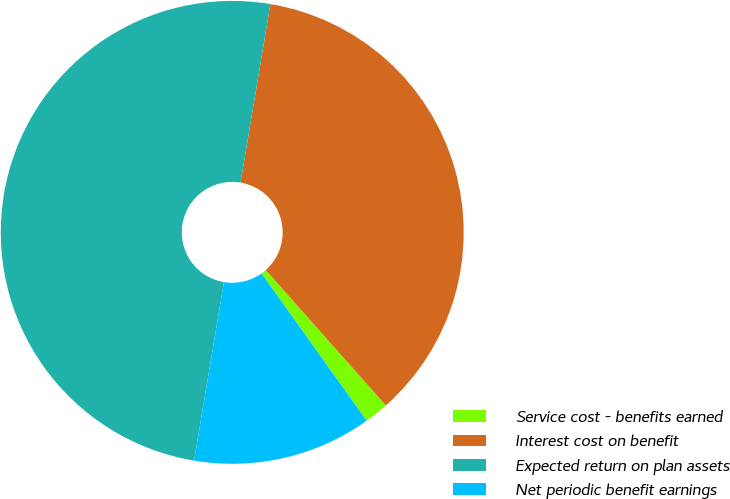<chart> <loc_0><loc_0><loc_500><loc_500><pie_chart><fcel>Service cost - benefits earned<fcel>Interest cost on benefit<fcel>Expected return on plan assets<fcel>Net periodic benefit earnings<nl><fcel>1.69%<fcel>35.81%<fcel>50.0%<fcel>12.5%<nl></chart> 